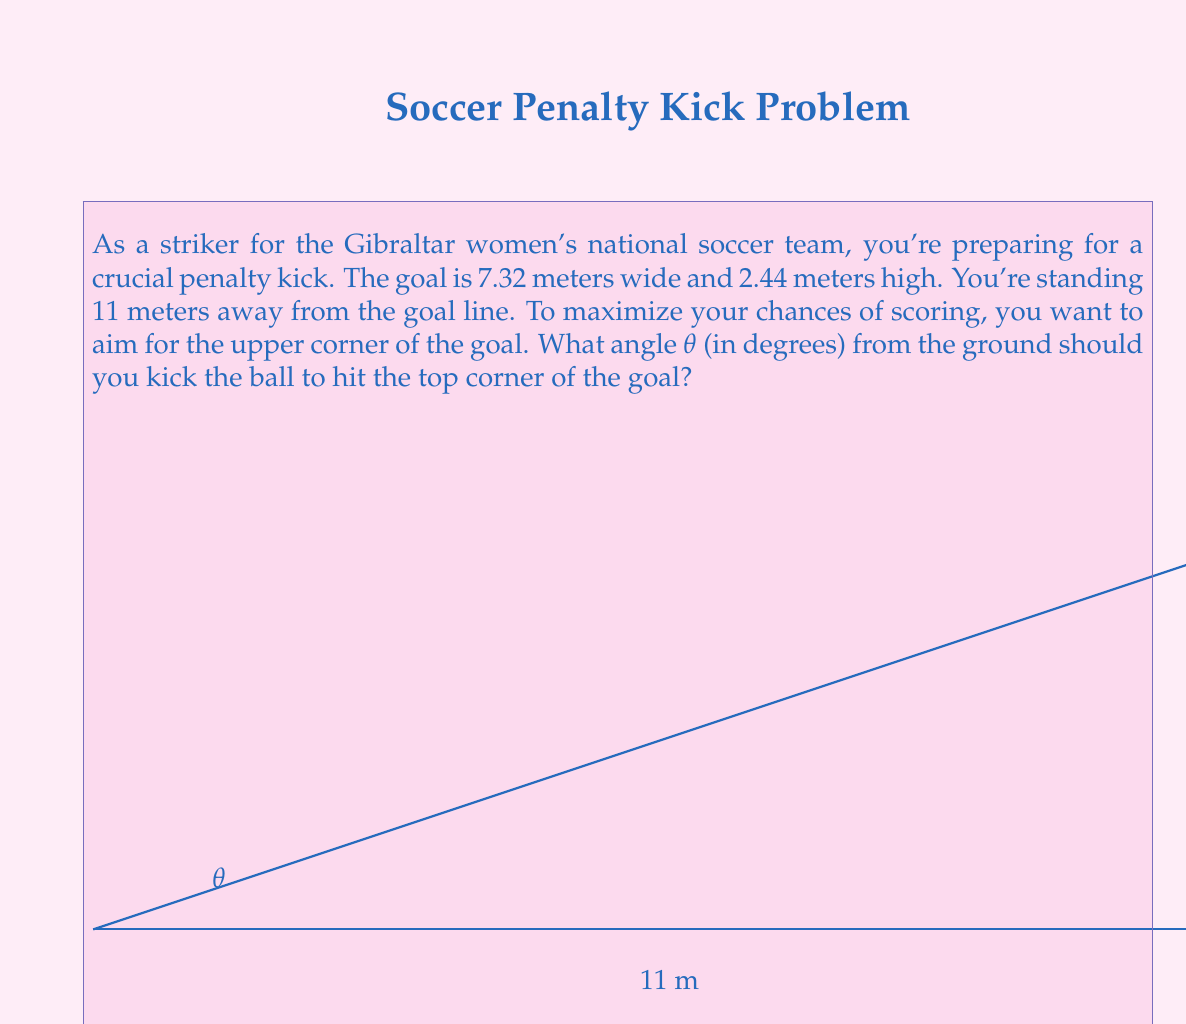Can you solve this math problem? Let's approach this step-by-step using trigonometry:

1) First, we need to consider the right triangle formed by the ball's trajectory:
   - The base of the triangle is 11 meters (distance to the goal)
   - The height is 2.44 meters (height of the goal)

2) We can use the tangent function to find the angle θ:

   $$\tan(\theta) = \frac{\text{opposite}}{\text{adjacent}} = \frac{\text{height}}{\text{distance}}$$

3) Substituting our values:

   $$\tan(\theta) = \frac{2.44}{11}$$

4) To find θ, we need to use the inverse tangent (arctan or $\tan^{-1}$):

   $$\theta = \tan^{-1}(\frac{2.44}{11})$$

5) Using a calculator or computer:

   $$\theta \approx 12.5121^\circ$$

6) Rounding to two decimal places:

   $$\theta \approx 12.51^\circ$$

Therefore, to hit the top corner of the goal, you should kick the ball at an angle of approximately 12.51° from the ground.
Answer: $12.51^\circ$ 